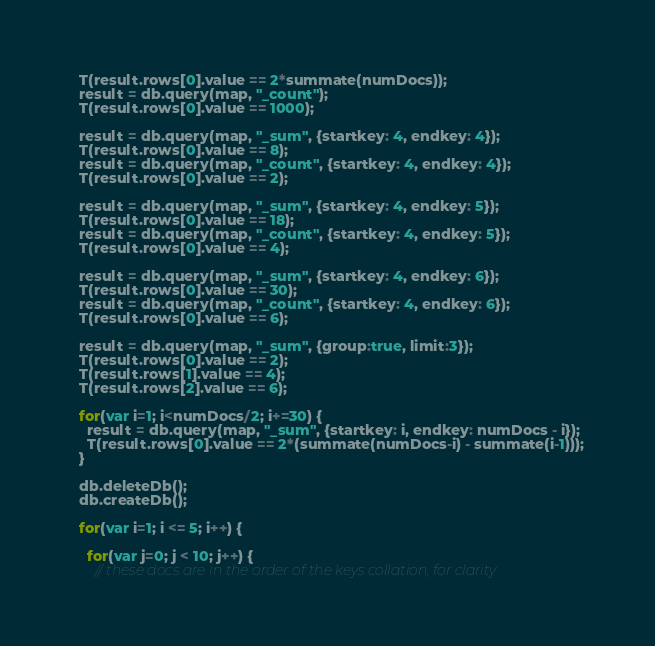<code> <loc_0><loc_0><loc_500><loc_500><_JavaScript_>  T(result.rows[0].value == 2*summate(numDocs));
  result = db.query(map, "_count");
  T(result.rows[0].value == 1000);

  result = db.query(map, "_sum", {startkey: 4, endkey: 4});
  T(result.rows[0].value == 8);
  result = db.query(map, "_count", {startkey: 4, endkey: 4});
  T(result.rows[0].value == 2);

  result = db.query(map, "_sum", {startkey: 4, endkey: 5});
  T(result.rows[0].value == 18);
  result = db.query(map, "_count", {startkey: 4, endkey: 5});
  T(result.rows[0].value == 4);

  result = db.query(map, "_sum", {startkey: 4, endkey: 6});
  T(result.rows[0].value == 30);
  result = db.query(map, "_count", {startkey: 4, endkey: 6});
  T(result.rows[0].value == 6);

  result = db.query(map, "_sum", {group:true, limit:3});
  T(result.rows[0].value == 2);
  T(result.rows[1].value == 4);
  T(result.rows[2].value == 6);

  for(var i=1; i<numDocs/2; i+=30) {
    result = db.query(map, "_sum", {startkey: i, endkey: numDocs - i});
    T(result.rows[0].value == 2*(summate(numDocs-i) - summate(i-1)));
  }

  db.deleteDb();
  db.createDb();

  for(var i=1; i <= 5; i++) {

    for(var j=0; j < 10; j++) {
      // these docs are in the order of the keys collation, for clarity</code> 